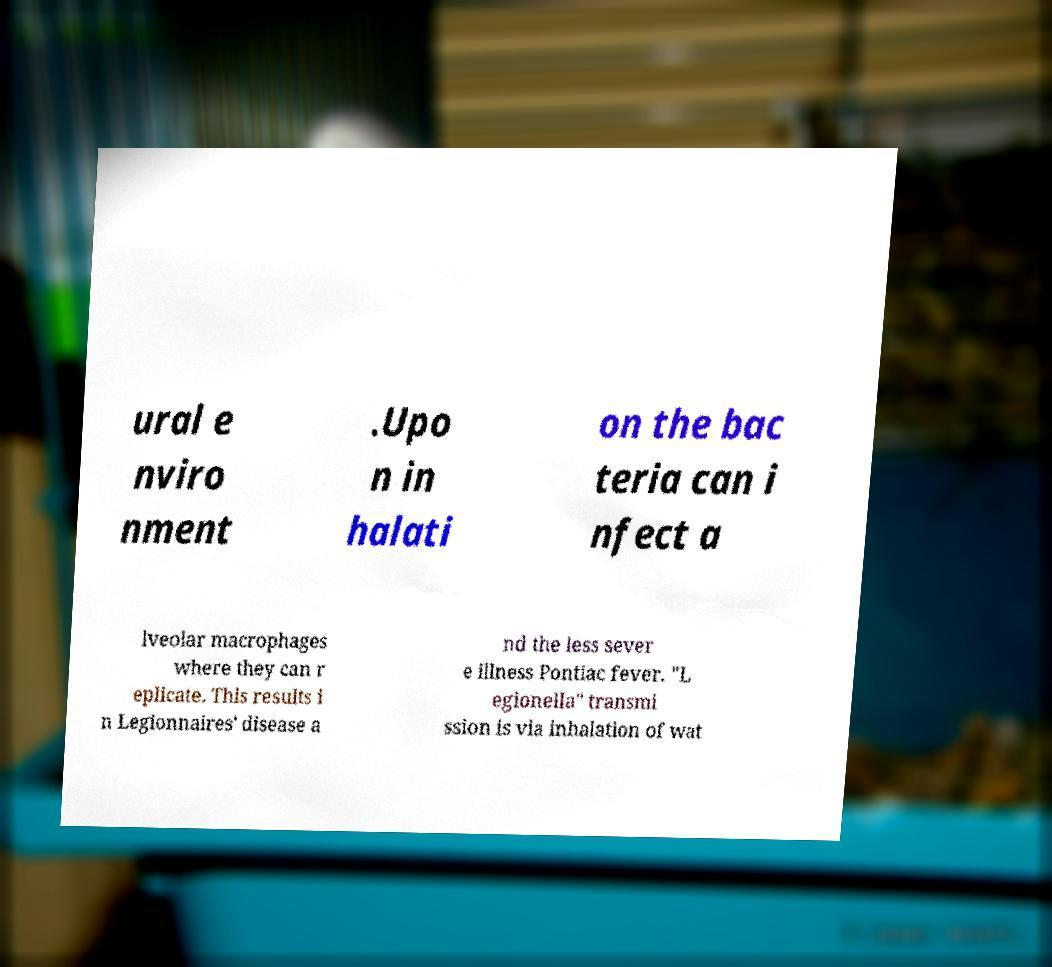Could you assist in decoding the text presented in this image and type it out clearly? ural e nviro nment .Upo n in halati on the bac teria can i nfect a lveolar macrophages where they can r eplicate. This results i n Legionnaires' disease a nd the less sever e illness Pontiac fever. "L egionella" transmi ssion is via inhalation of wat 